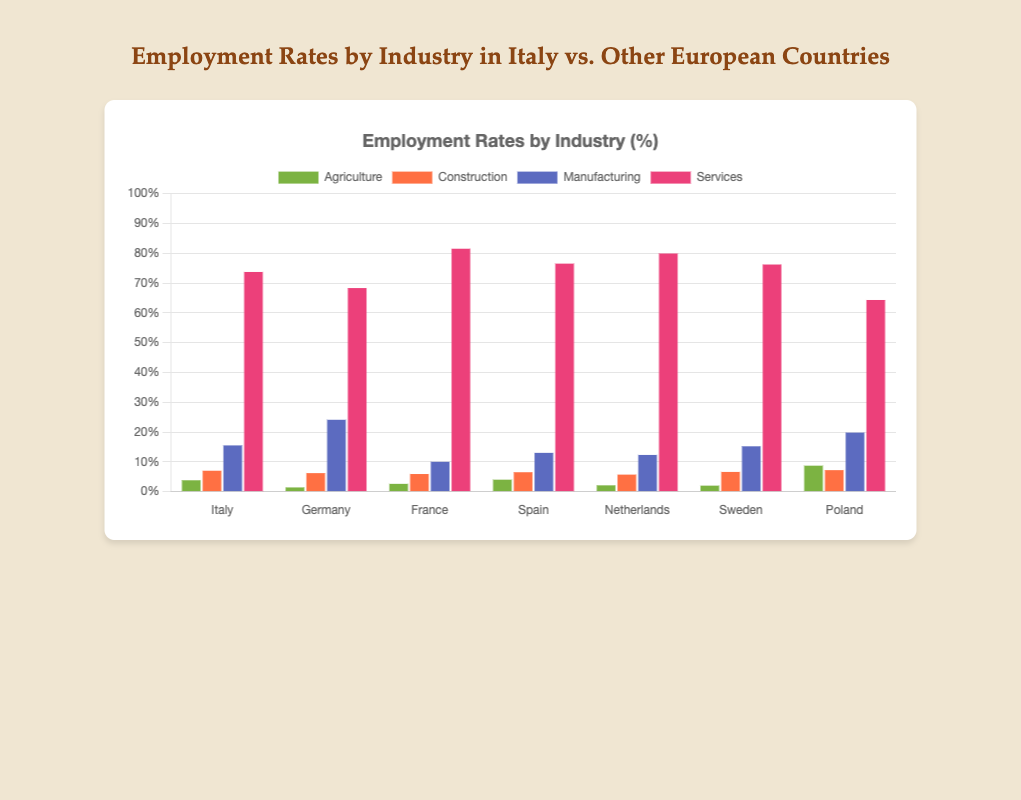Which industry has the highest employment rate in Italy? Look at the bars representing Italy; the Services bar is the tallest among all industries.
Answer: Services How do the employment rates in Agriculture in Germany and Poland compare? Compare the height of the Agriculture bars for Germany and Poland; Poland's Agriculture bar is significantly taller.
Answer: Poland's Agriculture rate is higher Which country has the lowest employment rate in Construction? Look at the bars for Construction across all countries; the Netherlands has the shortest bar.
Answer: Netherlands What is the difference in Manufacturing employment rates between Italy and Germany? Subtract the Manufacturing employment rate of Italy (15.5) from Germany (24.1). 24.1 - 15.5 = 8.6
Answer: 8.6 Which country shows the highest employment rate in Services? Observe the Services bars across all countries; France has the tallest bar.
Answer: France What is the combined employment rate for Agriculture and Construction in Spain? Add the employment rates for Agriculture (4.0) and Construction (6.5) in Spain. 4.0 + 6.5 = 10.5
Answer: 10.5 What is the average employment rate in Manufacturing across all the listed countries? Sum the Manufacturing employment rates for all countries: 15.5 (Italy) + 24.1 (Germany) + 10.0 (France) + 13.0 (Spain) + 12.3 (Netherlands) + 15.2 (Sweden) + 19.8 (Poland) = 109.9. Then divide by the number of countries (7). 109.9 / 7 ≈ 15.7
Answer: 15.7 Compare the employment rates in Services between Sweden and Italy. Which one is higher? Compare the heights of the Services bars for Sweden and Italy; Italy's Services employment rate is slightly higher.
Answer: Italy Which industry in Netherlands has the lowest employment rate? Look at the bars for Netherlands; Agriculture bar is the shortest.
Answer: Agriculture How much higher is the Services employment rate in France than in Germany? Subtract the Services employment rate of Germany (68.3) from France (81.5). 81.5 - 68.3 = 13.2
Answer: 13.2 